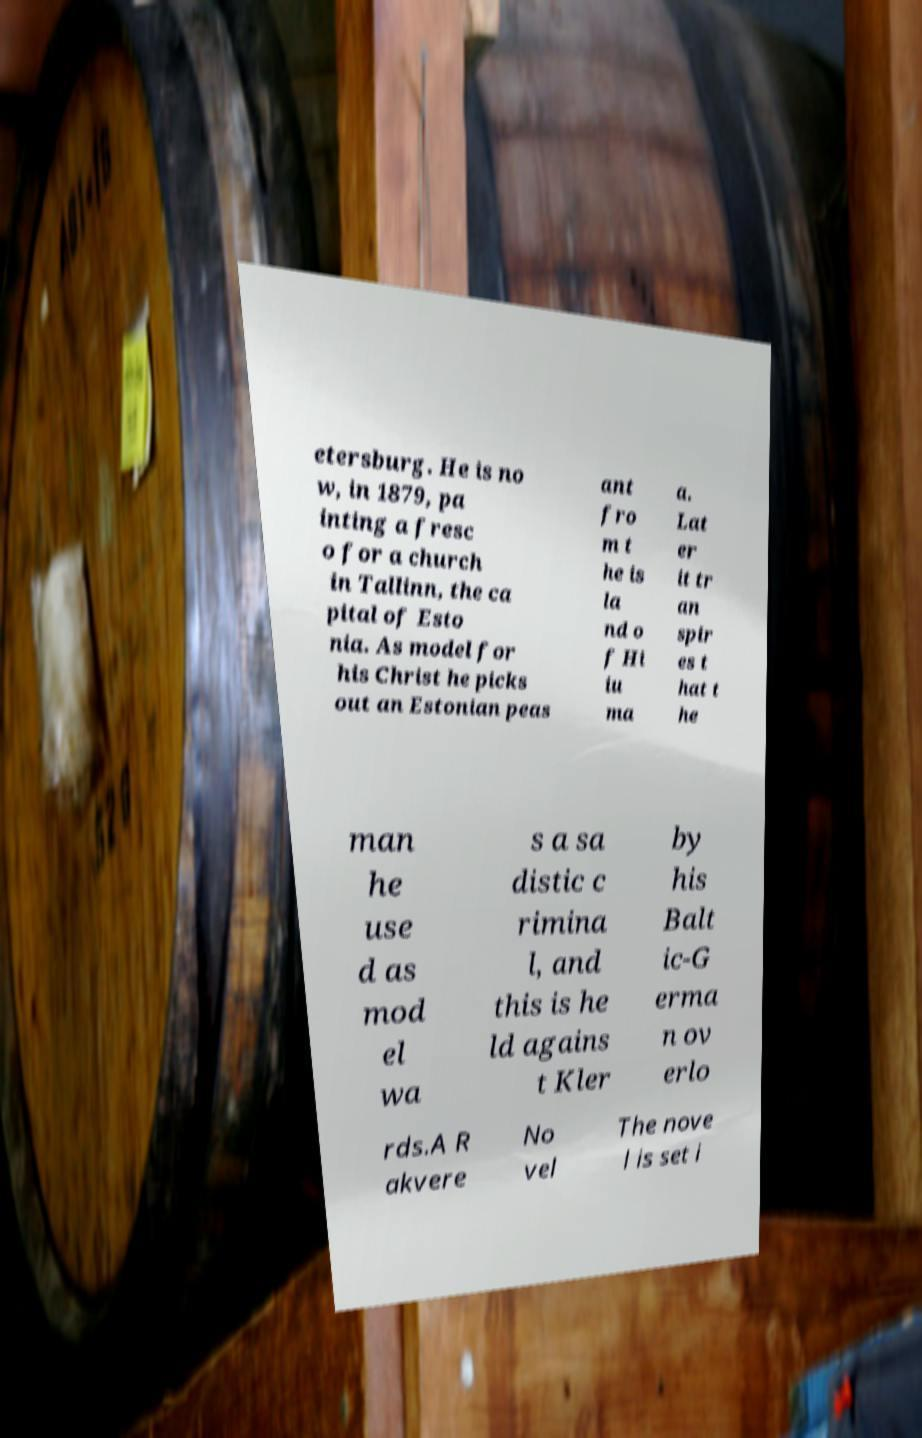What messages or text are displayed in this image? I need them in a readable, typed format. etersburg. He is no w, in 1879, pa inting a fresc o for a church in Tallinn, the ca pital of Esto nia. As model for his Christ he picks out an Estonian peas ant fro m t he is la nd o f Hi iu ma a. Lat er it tr an spir es t hat t he man he use d as mod el wa s a sa distic c rimina l, and this is he ld agains t Kler by his Balt ic-G erma n ov erlo rds.A R akvere No vel The nove l is set i 